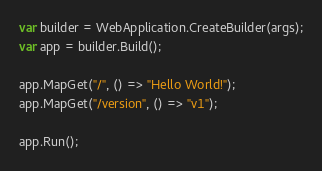Convert code to text. <code><loc_0><loc_0><loc_500><loc_500><_C#_>var builder = WebApplication.CreateBuilder(args);
var app = builder.Build();

app.MapGet("/", () => "Hello World!");
app.MapGet("/version", () => "v1");

app.Run();
</code> 